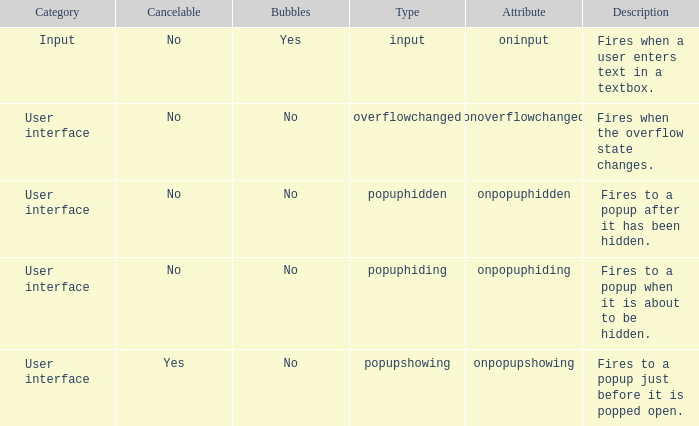 how many bubbles with category being input 1.0. 